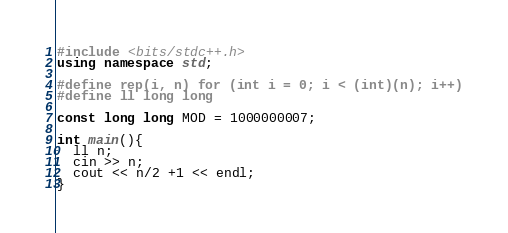<code> <loc_0><loc_0><loc_500><loc_500><_C++_>#include <bits/stdc++.h>
using namespace std;

#define rep(i, n) for (int i = 0; i < (int)(n); i++)
#define ll long long

const long long MOD = 1000000007;

int main(){
  ll n;
  cin >> n;
  cout << n/2 +1 << endl;
}
</code> 